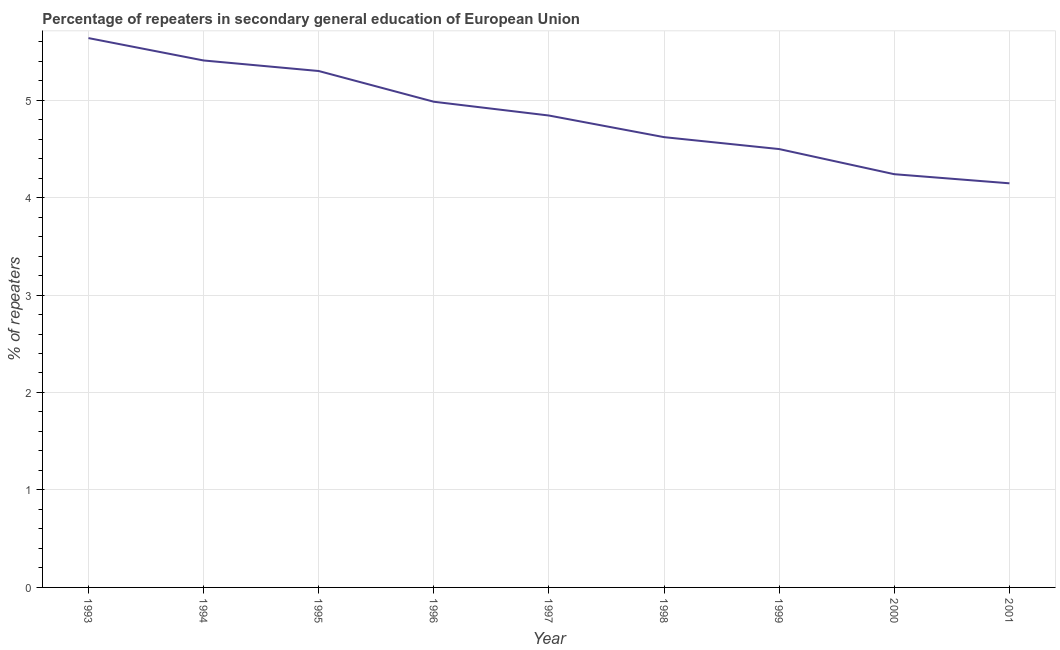What is the percentage of repeaters in 1997?
Provide a succinct answer. 4.84. Across all years, what is the maximum percentage of repeaters?
Provide a succinct answer. 5.64. Across all years, what is the minimum percentage of repeaters?
Offer a terse response. 4.15. What is the sum of the percentage of repeaters?
Provide a succinct answer. 43.67. What is the difference between the percentage of repeaters in 1997 and 2001?
Provide a short and direct response. 0.7. What is the average percentage of repeaters per year?
Offer a terse response. 4.85. What is the median percentage of repeaters?
Your answer should be very brief. 4.84. Do a majority of the years between 1994 and 1997 (inclusive) have percentage of repeaters greater than 0.4 %?
Your answer should be very brief. Yes. What is the ratio of the percentage of repeaters in 1994 to that in 1997?
Offer a very short reply. 1.12. Is the percentage of repeaters in 1994 less than that in 2000?
Make the answer very short. No. Is the difference between the percentage of repeaters in 1998 and 2000 greater than the difference between any two years?
Ensure brevity in your answer.  No. What is the difference between the highest and the second highest percentage of repeaters?
Offer a very short reply. 0.23. What is the difference between the highest and the lowest percentage of repeaters?
Provide a short and direct response. 1.49. In how many years, is the percentage of repeaters greater than the average percentage of repeaters taken over all years?
Ensure brevity in your answer.  4. How many lines are there?
Make the answer very short. 1. How many years are there in the graph?
Offer a terse response. 9. Does the graph contain any zero values?
Offer a terse response. No. What is the title of the graph?
Offer a very short reply. Percentage of repeaters in secondary general education of European Union. What is the label or title of the X-axis?
Offer a very short reply. Year. What is the label or title of the Y-axis?
Give a very brief answer. % of repeaters. What is the % of repeaters of 1993?
Keep it short and to the point. 5.64. What is the % of repeaters in 1994?
Your answer should be compact. 5.41. What is the % of repeaters of 1995?
Offer a very short reply. 5.3. What is the % of repeaters of 1996?
Provide a succinct answer. 4.98. What is the % of repeaters in 1997?
Offer a very short reply. 4.84. What is the % of repeaters of 1998?
Your answer should be very brief. 4.62. What is the % of repeaters of 1999?
Give a very brief answer. 4.5. What is the % of repeaters of 2000?
Provide a short and direct response. 4.24. What is the % of repeaters of 2001?
Give a very brief answer. 4.15. What is the difference between the % of repeaters in 1993 and 1994?
Your answer should be very brief. 0.23. What is the difference between the % of repeaters in 1993 and 1995?
Your response must be concise. 0.34. What is the difference between the % of repeaters in 1993 and 1996?
Keep it short and to the point. 0.65. What is the difference between the % of repeaters in 1993 and 1997?
Give a very brief answer. 0.79. What is the difference between the % of repeaters in 1993 and 1998?
Provide a succinct answer. 1.02. What is the difference between the % of repeaters in 1993 and 1999?
Your answer should be compact. 1.14. What is the difference between the % of repeaters in 1993 and 2000?
Provide a succinct answer. 1.4. What is the difference between the % of repeaters in 1993 and 2001?
Provide a succinct answer. 1.49. What is the difference between the % of repeaters in 1994 and 1995?
Offer a terse response. 0.11. What is the difference between the % of repeaters in 1994 and 1996?
Provide a succinct answer. 0.42. What is the difference between the % of repeaters in 1994 and 1997?
Keep it short and to the point. 0.56. What is the difference between the % of repeaters in 1994 and 1998?
Make the answer very short. 0.79. What is the difference between the % of repeaters in 1994 and 1999?
Provide a short and direct response. 0.91. What is the difference between the % of repeaters in 1994 and 2000?
Your answer should be very brief. 1.17. What is the difference between the % of repeaters in 1994 and 2001?
Keep it short and to the point. 1.26. What is the difference between the % of repeaters in 1995 and 1996?
Provide a succinct answer. 0.32. What is the difference between the % of repeaters in 1995 and 1997?
Your response must be concise. 0.46. What is the difference between the % of repeaters in 1995 and 1998?
Your response must be concise. 0.68. What is the difference between the % of repeaters in 1995 and 1999?
Offer a terse response. 0.8. What is the difference between the % of repeaters in 1995 and 2000?
Give a very brief answer. 1.06. What is the difference between the % of repeaters in 1995 and 2001?
Keep it short and to the point. 1.15. What is the difference between the % of repeaters in 1996 and 1997?
Provide a short and direct response. 0.14. What is the difference between the % of repeaters in 1996 and 1998?
Provide a short and direct response. 0.36. What is the difference between the % of repeaters in 1996 and 1999?
Keep it short and to the point. 0.49. What is the difference between the % of repeaters in 1996 and 2000?
Your answer should be compact. 0.74. What is the difference between the % of repeaters in 1996 and 2001?
Your answer should be very brief. 0.84. What is the difference between the % of repeaters in 1997 and 1998?
Offer a terse response. 0.22. What is the difference between the % of repeaters in 1997 and 1999?
Offer a very short reply. 0.34. What is the difference between the % of repeaters in 1997 and 2000?
Your response must be concise. 0.6. What is the difference between the % of repeaters in 1997 and 2001?
Keep it short and to the point. 0.7. What is the difference between the % of repeaters in 1998 and 1999?
Give a very brief answer. 0.12. What is the difference between the % of repeaters in 1998 and 2000?
Ensure brevity in your answer.  0.38. What is the difference between the % of repeaters in 1998 and 2001?
Give a very brief answer. 0.47. What is the difference between the % of repeaters in 1999 and 2000?
Provide a short and direct response. 0.26. What is the difference between the % of repeaters in 1999 and 2001?
Your answer should be compact. 0.35. What is the difference between the % of repeaters in 2000 and 2001?
Your response must be concise. 0.09. What is the ratio of the % of repeaters in 1993 to that in 1994?
Your response must be concise. 1.04. What is the ratio of the % of repeaters in 1993 to that in 1995?
Make the answer very short. 1.06. What is the ratio of the % of repeaters in 1993 to that in 1996?
Offer a very short reply. 1.13. What is the ratio of the % of repeaters in 1993 to that in 1997?
Your response must be concise. 1.16. What is the ratio of the % of repeaters in 1993 to that in 1998?
Provide a short and direct response. 1.22. What is the ratio of the % of repeaters in 1993 to that in 1999?
Your response must be concise. 1.25. What is the ratio of the % of repeaters in 1993 to that in 2000?
Your answer should be very brief. 1.33. What is the ratio of the % of repeaters in 1993 to that in 2001?
Ensure brevity in your answer.  1.36. What is the ratio of the % of repeaters in 1994 to that in 1995?
Offer a very short reply. 1.02. What is the ratio of the % of repeaters in 1994 to that in 1996?
Offer a very short reply. 1.08. What is the ratio of the % of repeaters in 1994 to that in 1997?
Offer a very short reply. 1.12. What is the ratio of the % of repeaters in 1994 to that in 1998?
Ensure brevity in your answer.  1.17. What is the ratio of the % of repeaters in 1994 to that in 1999?
Give a very brief answer. 1.2. What is the ratio of the % of repeaters in 1994 to that in 2000?
Offer a very short reply. 1.27. What is the ratio of the % of repeaters in 1994 to that in 2001?
Your response must be concise. 1.3. What is the ratio of the % of repeaters in 1995 to that in 1996?
Provide a short and direct response. 1.06. What is the ratio of the % of repeaters in 1995 to that in 1997?
Your response must be concise. 1.09. What is the ratio of the % of repeaters in 1995 to that in 1998?
Your answer should be very brief. 1.15. What is the ratio of the % of repeaters in 1995 to that in 1999?
Your response must be concise. 1.18. What is the ratio of the % of repeaters in 1995 to that in 2001?
Ensure brevity in your answer.  1.28. What is the ratio of the % of repeaters in 1996 to that in 1998?
Make the answer very short. 1.08. What is the ratio of the % of repeaters in 1996 to that in 1999?
Provide a succinct answer. 1.11. What is the ratio of the % of repeaters in 1996 to that in 2000?
Keep it short and to the point. 1.18. What is the ratio of the % of repeaters in 1996 to that in 2001?
Offer a terse response. 1.2. What is the ratio of the % of repeaters in 1997 to that in 1998?
Make the answer very short. 1.05. What is the ratio of the % of repeaters in 1997 to that in 1999?
Provide a short and direct response. 1.08. What is the ratio of the % of repeaters in 1997 to that in 2000?
Your answer should be compact. 1.14. What is the ratio of the % of repeaters in 1997 to that in 2001?
Give a very brief answer. 1.17. What is the ratio of the % of repeaters in 1998 to that in 1999?
Keep it short and to the point. 1.03. What is the ratio of the % of repeaters in 1998 to that in 2000?
Keep it short and to the point. 1.09. What is the ratio of the % of repeaters in 1998 to that in 2001?
Your answer should be very brief. 1.11. What is the ratio of the % of repeaters in 1999 to that in 2000?
Offer a terse response. 1.06. What is the ratio of the % of repeaters in 1999 to that in 2001?
Offer a terse response. 1.08. What is the ratio of the % of repeaters in 2000 to that in 2001?
Provide a succinct answer. 1.02. 